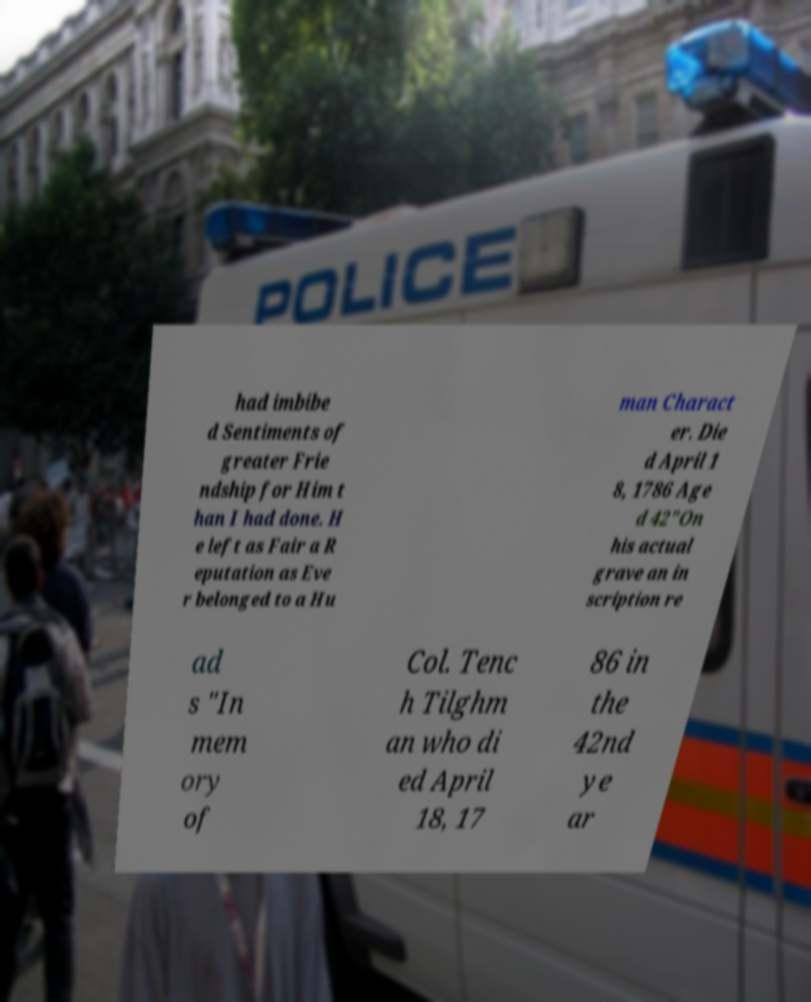What messages or text are displayed in this image? I need them in a readable, typed format. had imbibe d Sentiments of greater Frie ndship for Him t han I had done. H e left as Fair a R eputation as Eve r belonged to a Hu man Charact er. Die d April 1 8, 1786 Age d 42"On his actual grave an in scription re ad s "In mem ory of Col. Tenc h Tilghm an who di ed April 18, 17 86 in the 42nd ye ar 